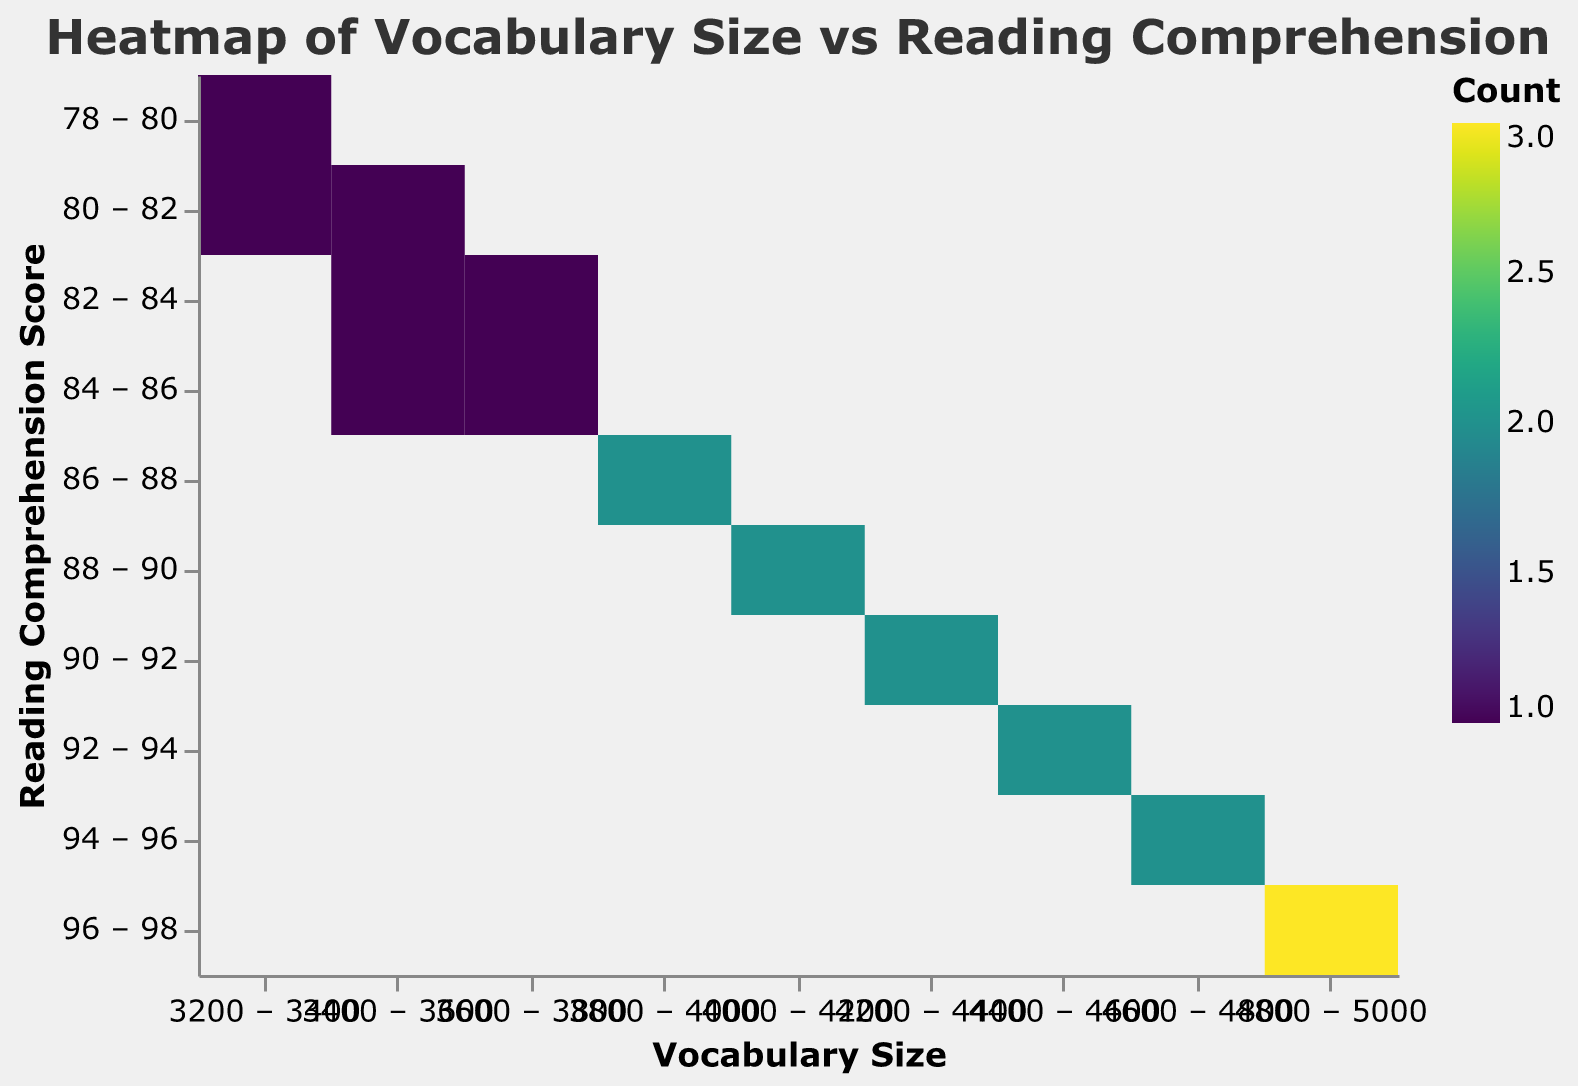How is the heatmap titled? The title of the heatmap is written at the top and usually describes the main subject of the visualization. In this case, it states the relationship between vocabulary size and reading comprehension.
Answer: Heatmap of Vocabulary Size vs Reading Comprehension What are the two variables being compared in the heatmap? The heatmap's x-axis and y-axis titles denote the variables being compared. Here, they are "Vocabulary Size" on the x-axis and "Reading Comprehension Score" on the y-axis.
Answer: Vocabulary Size and Reading Comprehension Score Which range of vocabulary size has the highest reading comprehension scores? To determine this, look for cells in the heatmap with the highest values (usually the darkest or most vibrant color) along the y-axis at the highest reading comprehension scores.
Answer: 4700 to 5000 How many data points fall into the highest reading comprehension score range of 95-98? Count the number of high-color-intensity cells in the 95-98 range along the y-axis.
Answer: 4 What's the general relationship observed between vocabulary size and reading comprehension score? Generally, by observing the trend in the heatmap, higher vocabulary sizes correspond to higher reading comprehension scores, indicated by regions with intense color moving towards the upper right of the heatmap.
Answer: Positive relationship Which vocabulary size range sees a significant increase in reading comprehension scores? Notice where the color intensity increases sharply on the heatmap. Here, significant change appears around vocabulary sizes of 3900 to 4500.
Answer: 3900 to 4500 At which vocabulary size range do reading comprehension scores start to stabilize at higher levels? Look at the upper parts of the heatmap where there is a consistent high intensity of color.
Answer: 4500 to 5000 Are there any vocabulary size ranges that generally correspond to lower reading comprehension scores? Identify areas with lighter or less intense colors in the heatmap. Vocabulary sizes in the 3200-3700 range correspond to lower comprehension scores.
Answer: 3200 to 3700 Is there any vocabulary size that matches with more than one reading comprehension score? Look for vertical cells with multiple color intensities in the heatmap. The vocabulary size range of 3400 to 3600 matches multiple reading comprehension scores from 81 to 84.
Answer: 3400 to 3600 Does every increase in vocabulary size lead to a higher reading comprehension score? Examine the entire heatmap to see if there's a one-to-one increase correlation. Notice some ranges overlap, indicating slight variations and not every increase leads directly to higher scores.
Answer: No 